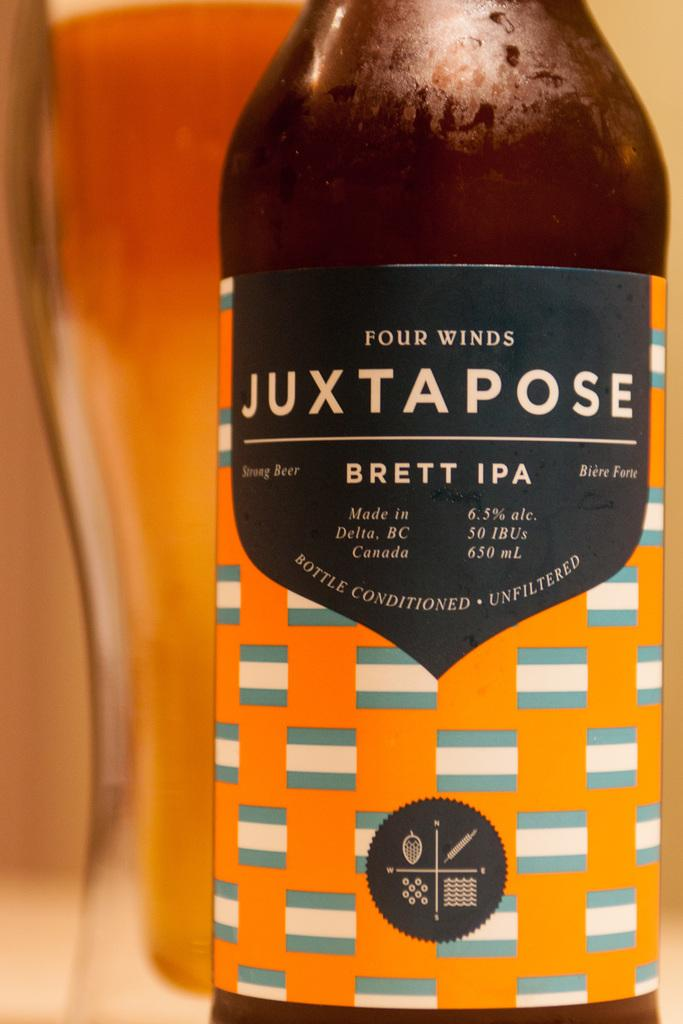<image>
Give a short and clear explanation of the subsequent image. Brett IPA from Four Winds is sitting in front of a glass full of beer. 